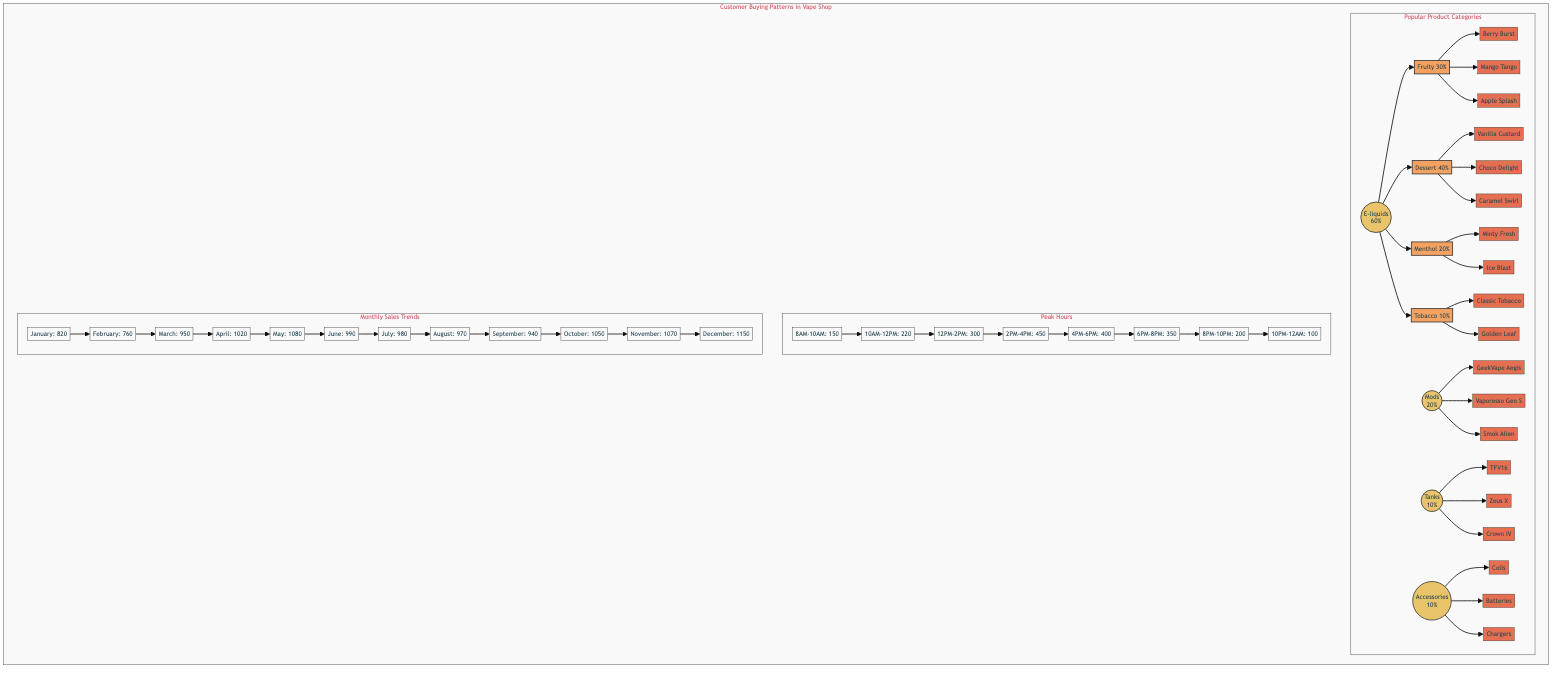What's the total monthly sales for December? The monthly sales for December is clearly stated as 1150 in the diagram.
Answer: 1150 What are the peak hours for customer traffic? The peak hours of customer traffic are indicated in the "Peak Hours" section, with the highest traffic being from 2PM-4PM at 450 customers.
Answer: 2PM-4PM How many product categories are represented in the diagram? The "Popular Product Categories" section shows four categories: E-liquids, Mods, Tanks, and Accessories.
Answer: 4 Which product is the top seller in the "E-liquids" category? In the "E-liquids" category, "Dessert" is the largest subcategory at 40%, indicating its prominence among the products listed, but "Vanilla Custard," "Choco Delight," and "Caramel Swirl" are part of this subcategory. Thus, "Vanilla Custard" can be considered the most representative product.
Answer: Vanilla Custard What is the percentage share of Mods in the overall product categories? The pie chart indicates Mods hold a 20% share of the total product categories as seen in the "Popular Product Categories" segment.
Answer: 20% 